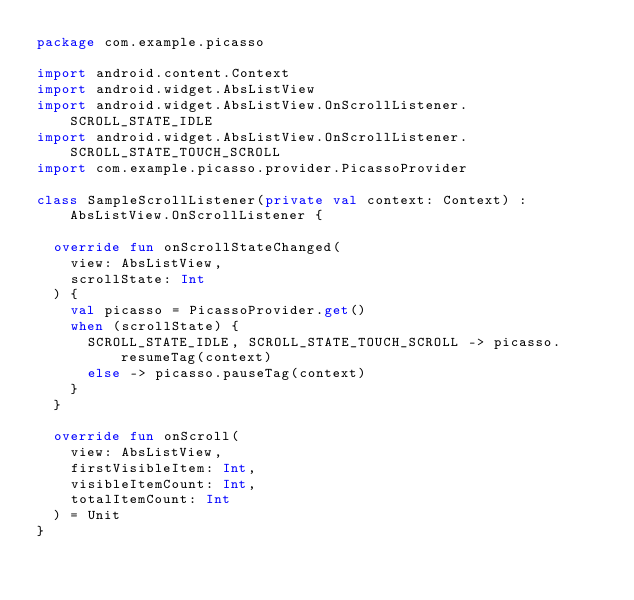<code> <loc_0><loc_0><loc_500><loc_500><_Kotlin_>package com.example.picasso

import android.content.Context
import android.widget.AbsListView
import android.widget.AbsListView.OnScrollListener.SCROLL_STATE_IDLE
import android.widget.AbsListView.OnScrollListener.SCROLL_STATE_TOUCH_SCROLL
import com.example.picasso.provider.PicassoProvider

class SampleScrollListener(private val context: Context) : AbsListView.OnScrollListener {

  override fun onScrollStateChanged(
    view: AbsListView,
    scrollState: Int
  ) {
    val picasso = PicassoProvider.get()
    when (scrollState) {
      SCROLL_STATE_IDLE, SCROLL_STATE_TOUCH_SCROLL -> picasso.resumeTag(context)
      else -> picasso.pauseTag(context)
    }
  }

  override fun onScroll(
    view: AbsListView,
    firstVisibleItem: Int,
    visibleItemCount: Int,
    totalItemCount: Int
  ) = Unit
}
</code> 